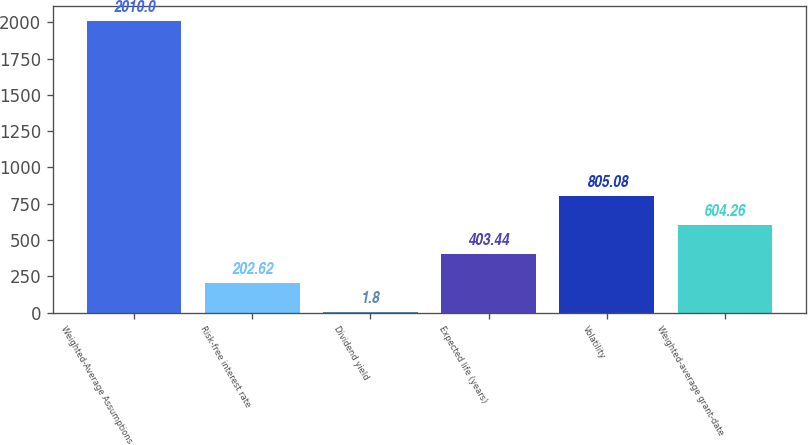Convert chart. <chart><loc_0><loc_0><loc_500><loc_500><bar_chart><fcel>Weighted-Average Assumptions<fcel>Risk-free interest rate<fcel>Dividend yield<fcel>Expected life (years)<fcel>Volatility<fcel>Weighted-average grant-date<nl><fcel>2010<fcel>202.62<fcel>1.8<fcel>403.44<fcel>805.08<fcel>604.26<nl></chart> 